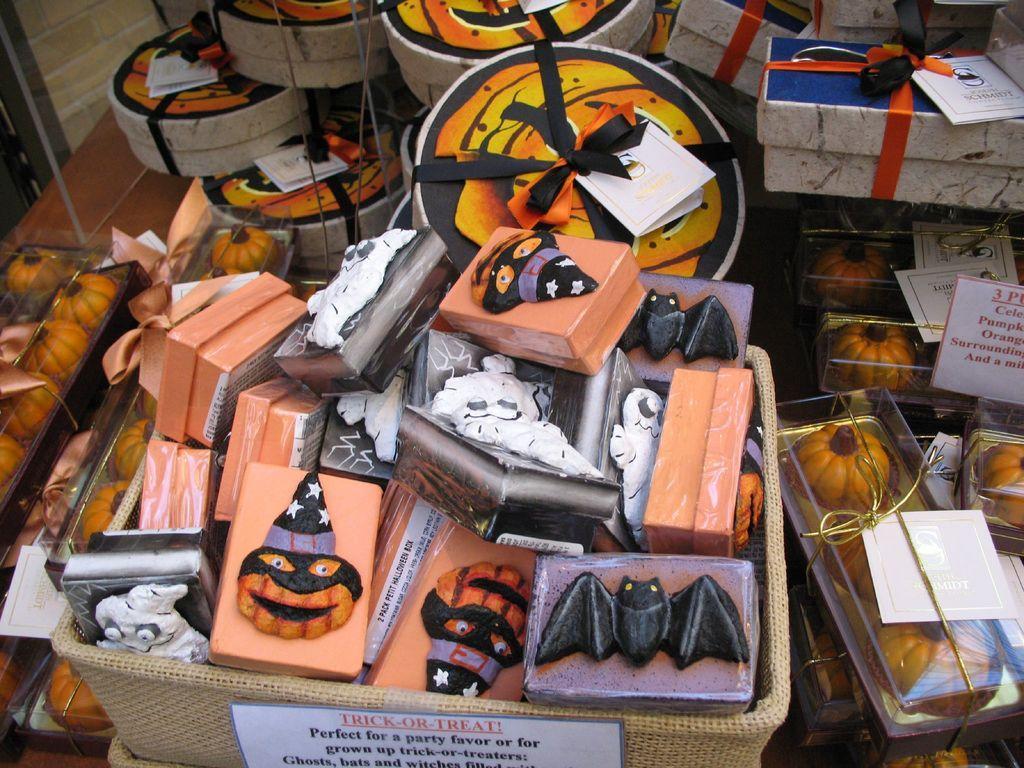Could you give a brief overview of what you see in this image? In this image we can see some boxes in the basket. On the right side we can see some pumpkins packed in the boxes. We can also see some gift boxes and some papers on it. 